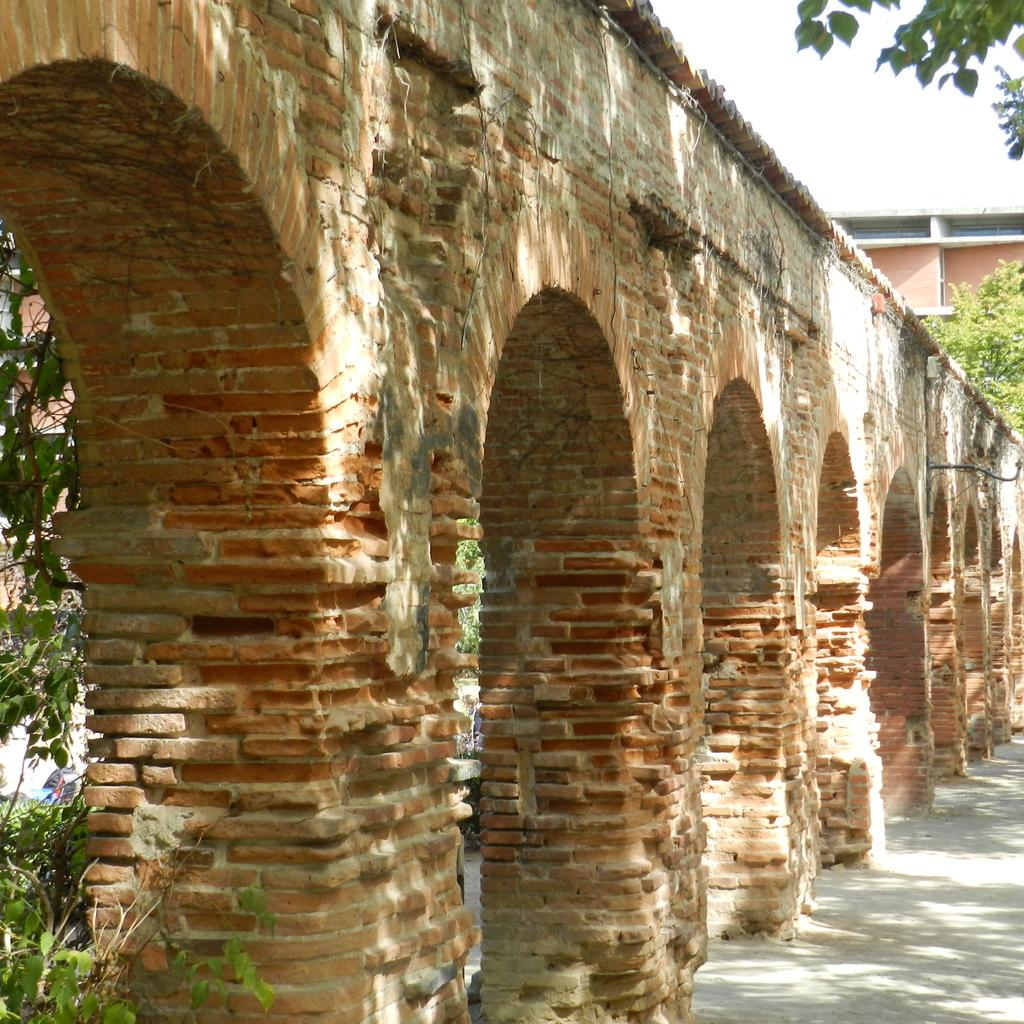What type of structure is present in the image? There is an architectural structure in the image. What can be seen in the background of the image? There are trees and plants, as well as a building, visible in the background of the image. What part of the natural environment is visible in the image? The sky is visible in the background of the image. What type of mark can be seen on the building in the image? There is no specific mark mentioned or visible on the building in the image. 